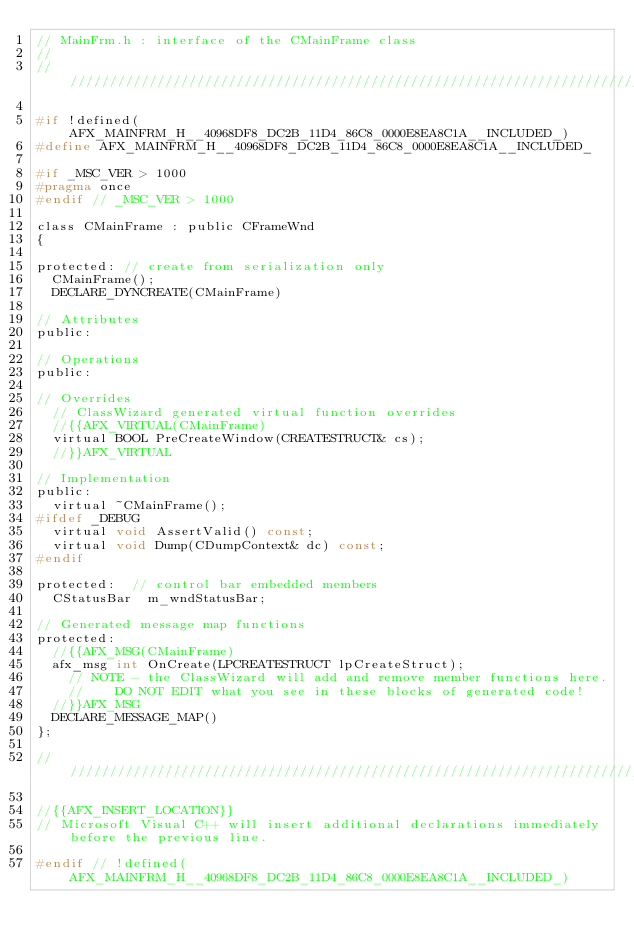Convert code to text. <code><loc_0><loc_0><loc_500><loc_500><_C_>// MainFrm.h : interface of the CMainFrame class
//
/////////////////////////////////////////////////////////////////////////////

#if !defined(AFX_MAINFRM_H__40968DF8_DC2B_11D4_86C8_0000E8EA8C1A__INCLUDED_)
#define AFX_MAINFRM_H__40968DF8_DC2B_11D4_86C8_0000E8EA8C1A__INCLUDED_

#if _MSC_VER > 1000
#pragma once
#endif // _MSC_VER > 1000

class CMainFrame : public CFrameWnd
{
	
protected: // create from serialization only
	CMainFrame();
	DECLARE_DYNCREATE(CMainFrame)

// Attributes
public:

// Operations
public:

// Overrides
	// ClassWizard generated virtual function overrides
	//{{AFX_VIRTUAL(CMainFrame)
	virtual BOOL PreCreateWindow(CREATESTRUCT& cs);
	//}}AFX_VIRTUAL

// Implementation
public:
	virtual ~CMainFrame();
#ifdef _DEBUG
	virtual void AssertValid() const;
	virtual void Dump(CDumpContext& dc) const;
#endif

protected:  // control bar embedded members
	CStatusBar  m_wndStatusBar;

// Generated message map functions
protected:
	//{{AFX_MSG(CMainFrame)
	afx_msg int OnCreate(LPCREATESTRUCT lpCreateStruct);
		// NOTE - the ClassWizard will add and remove member functions here.
		//    DO NOT EDIT what you see in these blocks of generated code!
	//}}AFX_MSG
	DECLARE_MESSAGE_MAP()
};

/////////////////////////////////////////////////////////////////////////////

//{{AFX_INSERT_LOCATION}}
// Microsoft Visual C++ will insert additional declarations immediately before the previous line.

#endif // !defined(AFX_MAINFRM_H__40968DF8_DC2B_11D4_86C8_0000E8EA8C1A__INCLUDED_)
</code> 